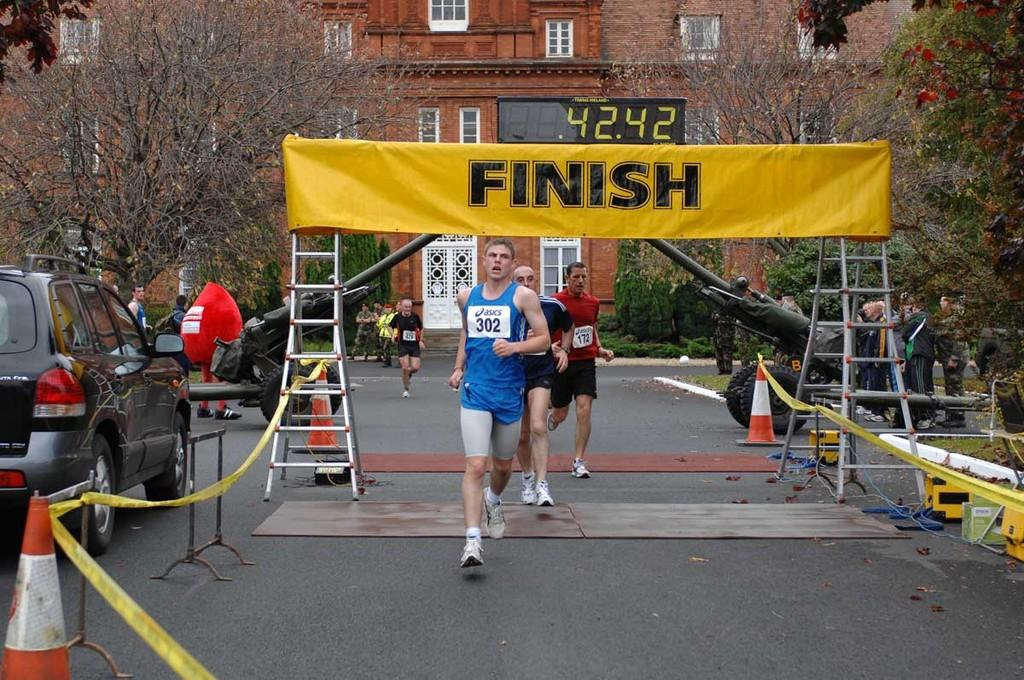Provide a one-sentence caption for the provided image. Three runners are crossing the yellow finish line. 